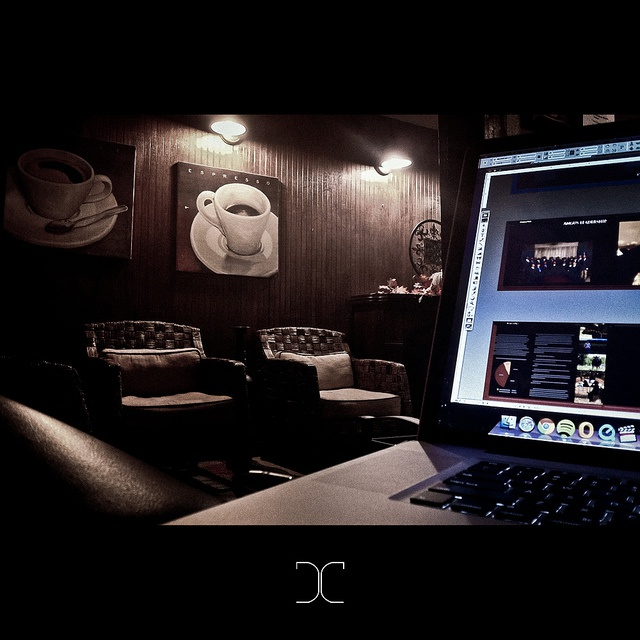Describe the objects in this image and their specific colors. I can see laptop in black, white, darkgray, and navy tones, chair in black, gray, and maroon tones, chair in black, darkgray, and gray tones, keyboard in black, navy, and gray tones, and cup in black, brown, and maroon tones in this image. 